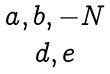Convert formula to latex. <formula><loc_0><loc_0><loc_500><loc_500>\begin{matrix} { a , b , - N } \\ { d , e } \end{matrix}</formula> 